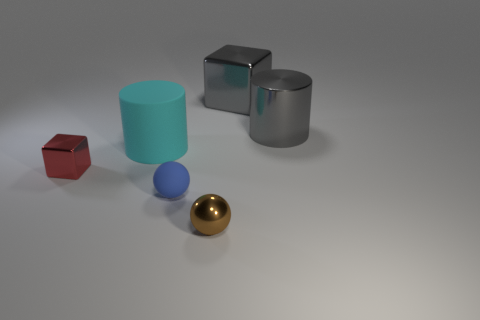What number of other things are there of the same color as the large matte cylinder?
Provide a short and direct response. 0. What shape is the tiny metallic object in front of the small red shiny thing?
Offer a terse response. Sphere. How many objects are small brown spheres or cyan shiny objects?
Make the answer very short. 1. Do the red object and the cylinder left of the large gray cube have the same size?
Provide a succinct answer. No. How many other objects are the same material as the big cyan object?
Your answer should be very brief. 1. What number of things are cylinders left of the shiny sphere or metallic things in front of the large cube?
Provide a succinct answer. 4. What is the material of the small blue object that is the same shape as the brown object?
Offer a very short reply. Rubber. Are any gray things visible?
Your answer should be very brief. Yes. There is a metal object that is both left of the gray metal cylinder and behind the cyan thing; what is its size?
Give a very brief answer. Large. The large rubber thing has what shape?
Give a very brief answer. Cylinder. 